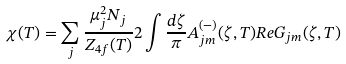<formula> <loc_0><loc_0><loc_500><loc_500>\chi ( T ) = \sum _ { j } \frac { \mu _ { j } ^ { 2 } N _ { j } } { Z _ { 4 f } ( T ) } 2 \int \frac { d \zeta } { \pi } A _ { j m } ^ { ( - ) } ( \zeta , T ) R e G _ { j m } ( \zeta , T )</formula> 